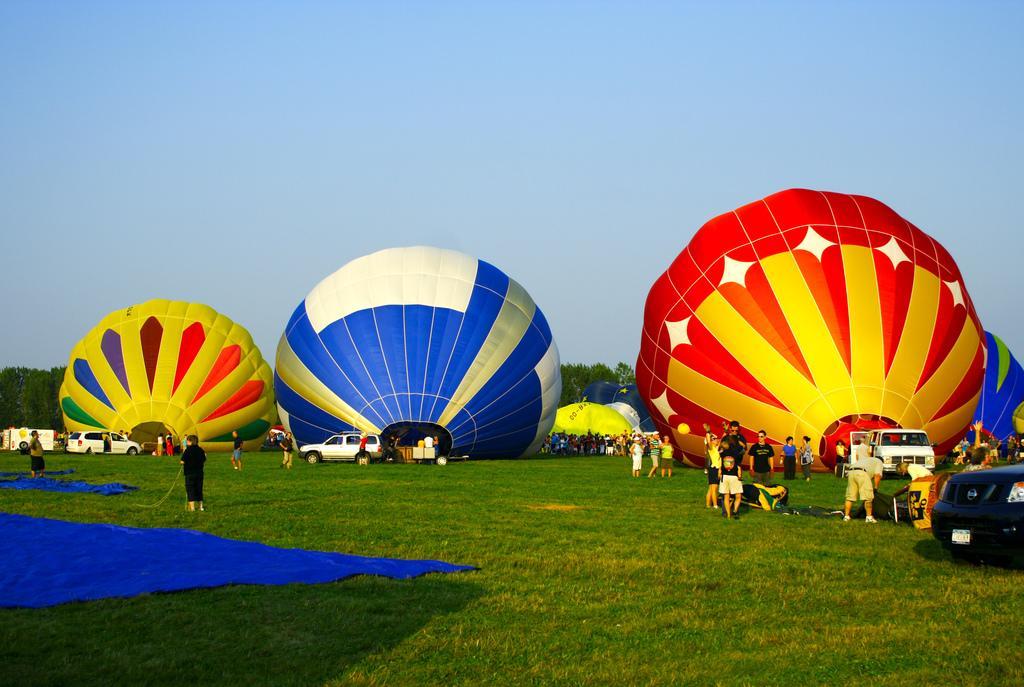How would you summarize this image in a sentence or two? There is grass on the ground. Also there is a blue color sheet. Also there are many people. Also there are balloons. In the background there is sky and trees. 